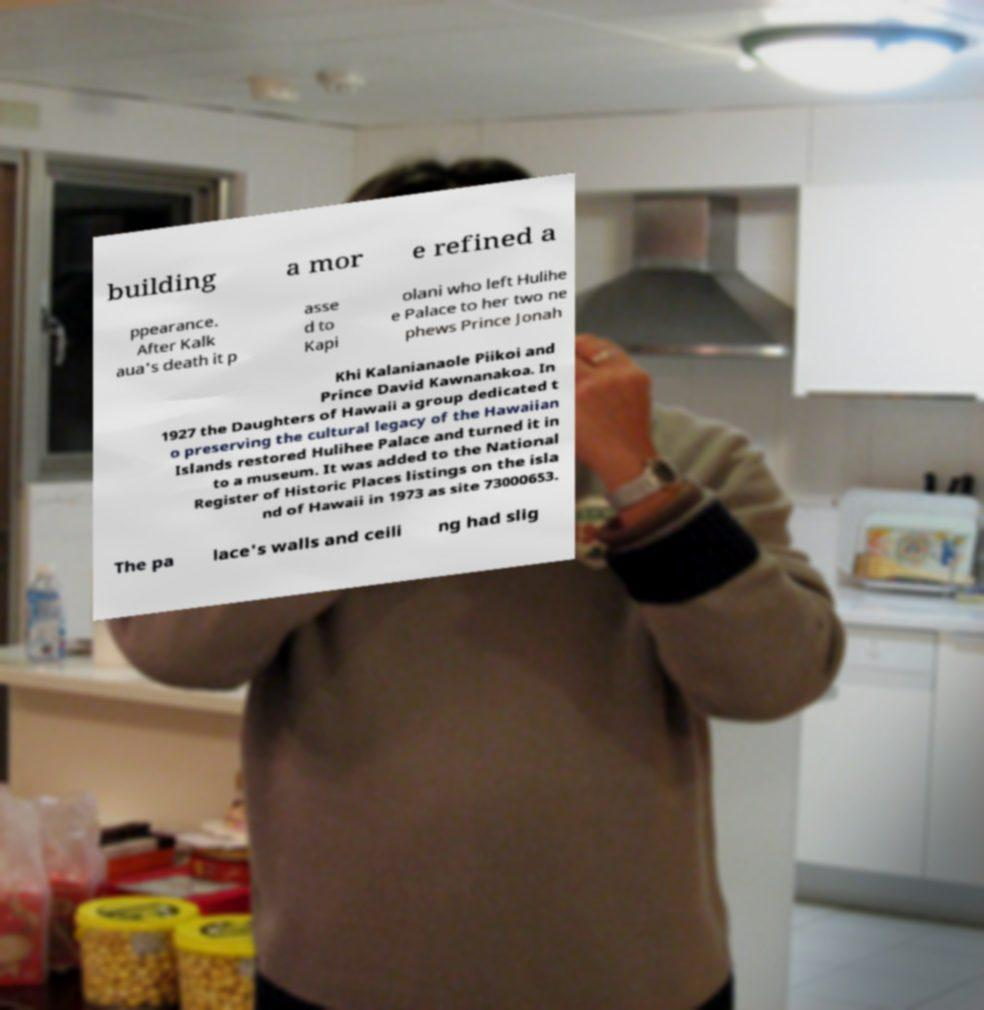For documentation purposes, I need the text within this image transcribed. Could you provide that? building a mor e refined a ppearance. After Kalk aua's death it p asse d to Kapi olani who left Hulihe e Palace to her two ne phews Prince Jonah Khi Kalanianaole Piikoi and Prince David Kawnanakoa. In 1927 the Daughters of Hawaii a group dedicated t o preserving the cultural legacy of the Hawaiian Islands restored Hulihee Palace and turned it in to a museum. It was added to the National Register of Historic Places listings on the isla nd of Hawaii in 1973 as site 73000653. The pa lace's walls and ceili ng had slig 